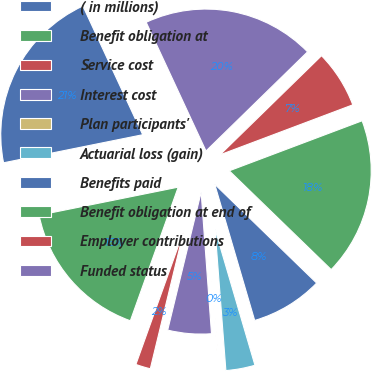Convert chart. <chart><loc_0><loc_0><loc_500><loc_500><pie_chart><fcel>( in millions)<fcel>Benefit obligation at<fcel>Service cost<fcel>Interest cost<fcel>Plan participants'<fcel>Actuarial loss (gain)<fcel>Benefits paid<fcel>Benefit obligation at end of<fcel>Employer contributions<fcel>Funded status<nl><fcel>21.25%<fcel>16.36%<fcel>1.69%<fcel>4.95%<fcel>0.06%<fcel>3.32%<fcel>8.21%<fcel>17.99%<fcel>6.58%<fcel>19.62%<nl></chart> 